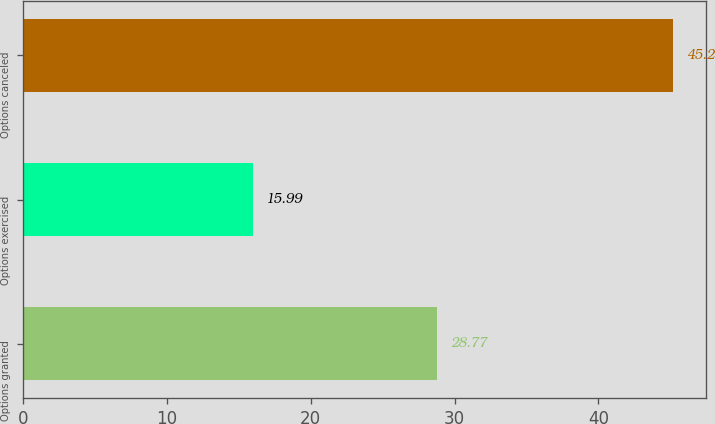Convert chart. <chart><loc_0><loc_0><loc_500><loc_500><bar_chart><fcel>Options granted<fcel>Options exercised<fcel>Options canceled<nl><fcel>28.77<fcel>15.99<fcel>45.2<nl></chart> 